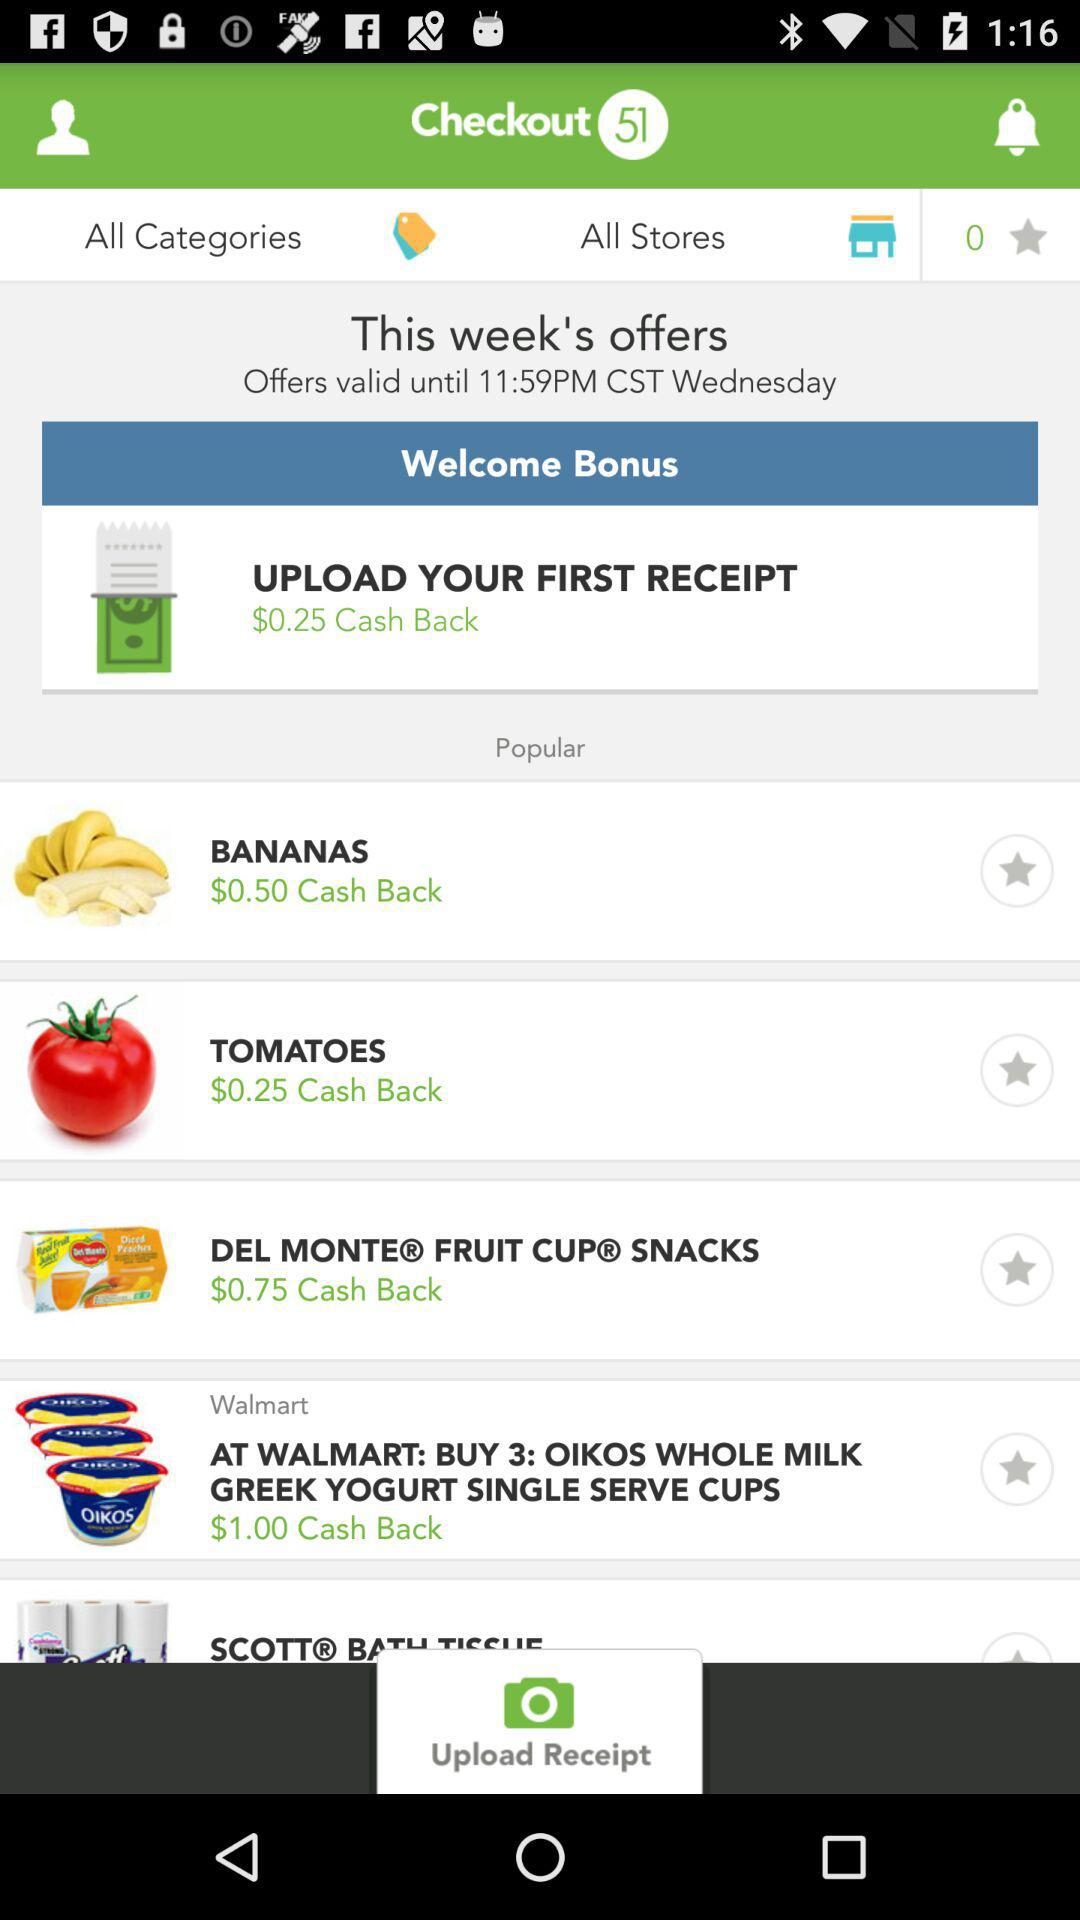How much cashback is there on bananas? There is $0.50 cashback on bananas. 